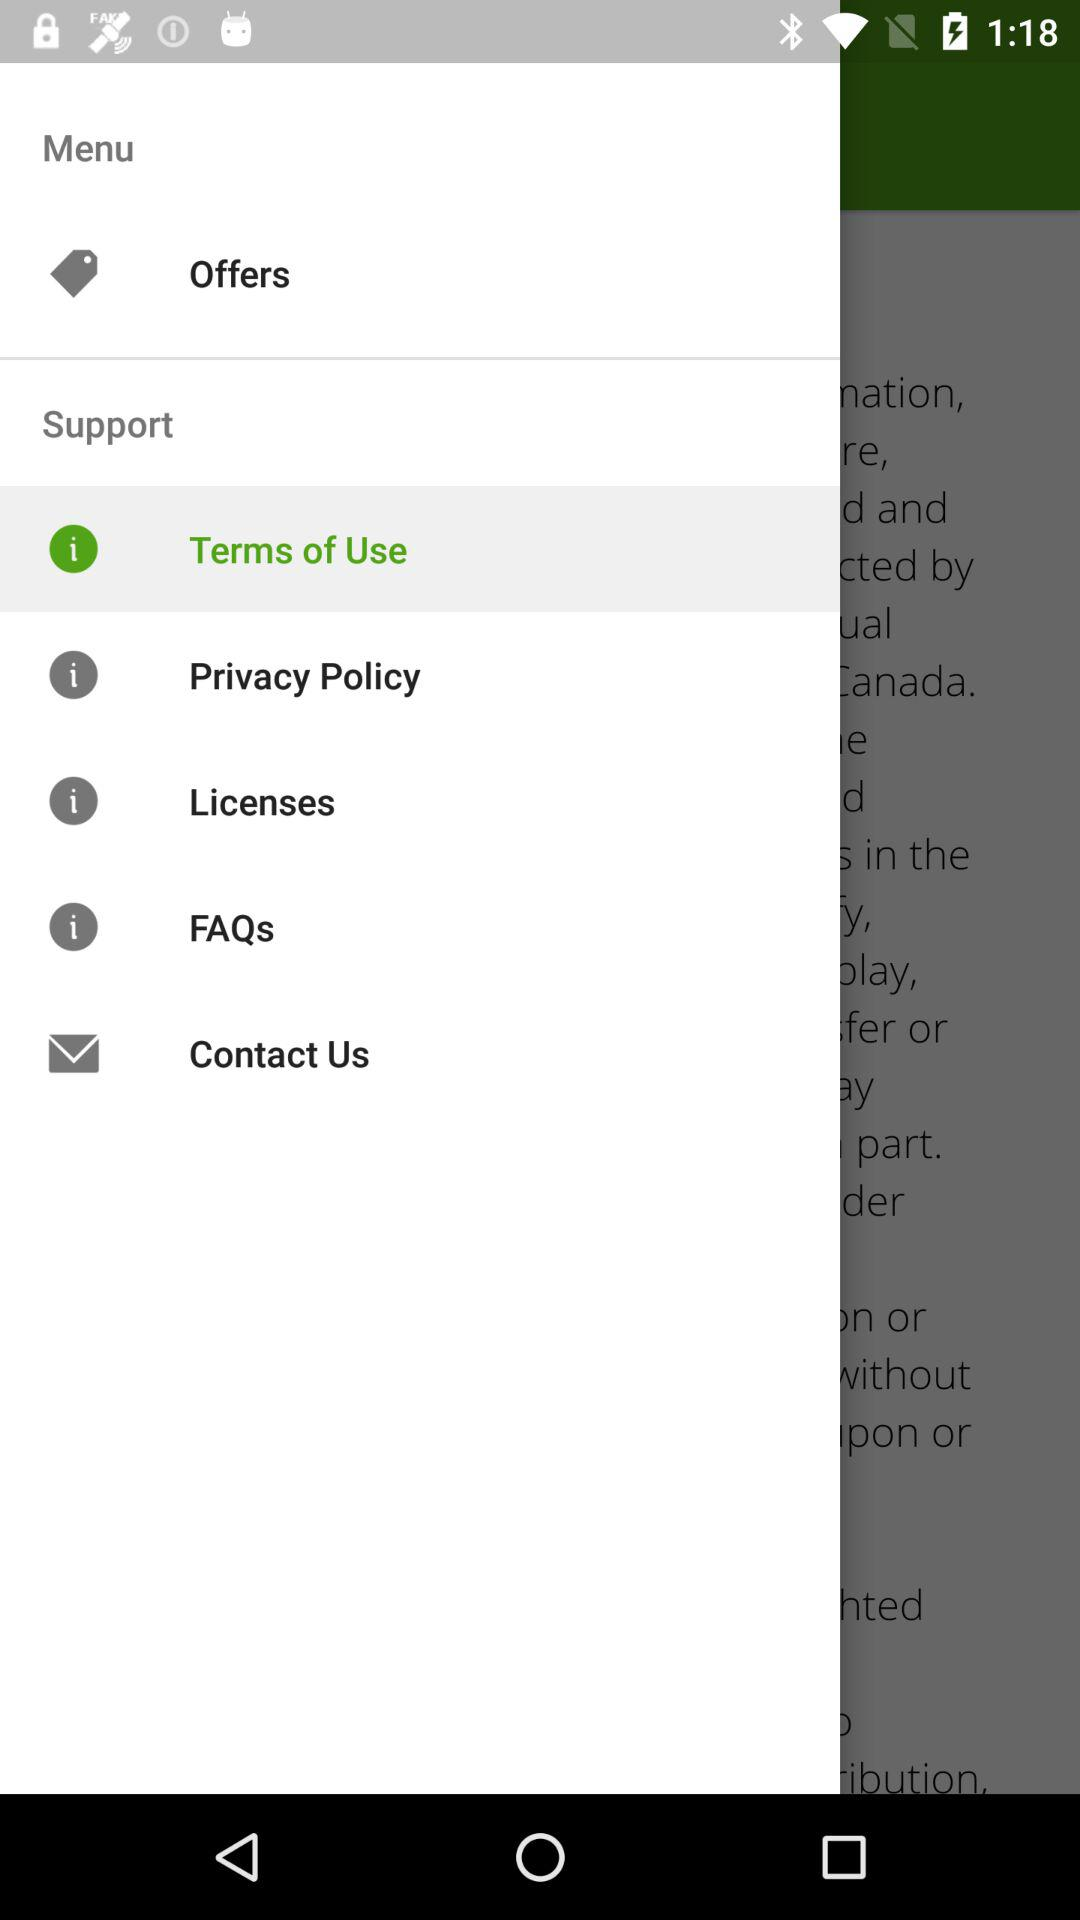What option is selected? The selected option is "Terms of Use". 